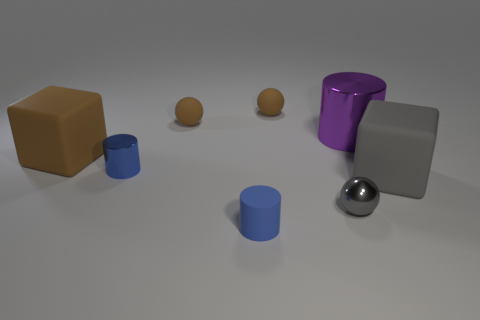The other cylinder that is the same color as the tiny shiny cylinder is what size?
Keep it short and to the point. Small. Do the small metallic cylinder and the rubber cylinder have the same color?
Your answer should be compact. Yes. What number of other objects are there of the same shape as the big gray object?
Make the answer very short. 1. Are there any other things that have the same color as the tiny matte cylinder?
Offer a terse response. Yes. What number of brown rubber things have the same size as the gray matte object?
Provide a short and direct response. 1. There is a thing that is behind the purple object and on the left side of the small blue matte cylinder; what is its material?
Your answer should be very brief. Rubber. What number of metallic objects are in front of the purple shiny thing?
Ensure brevity in your answer.  2. Do the blue shiny thing and the brown matte thing that is in front of the purple shiny cylinder have the same shape?
Provide a short and direct response. No. Are there any big brown things of the same shape as the big gray rubber object?
Give a very brief answer. Yes. What is the shape of the large object that is behind the large block on the left side of the large purple metal cylinder?
Give a very brief answer. Cylinder. 